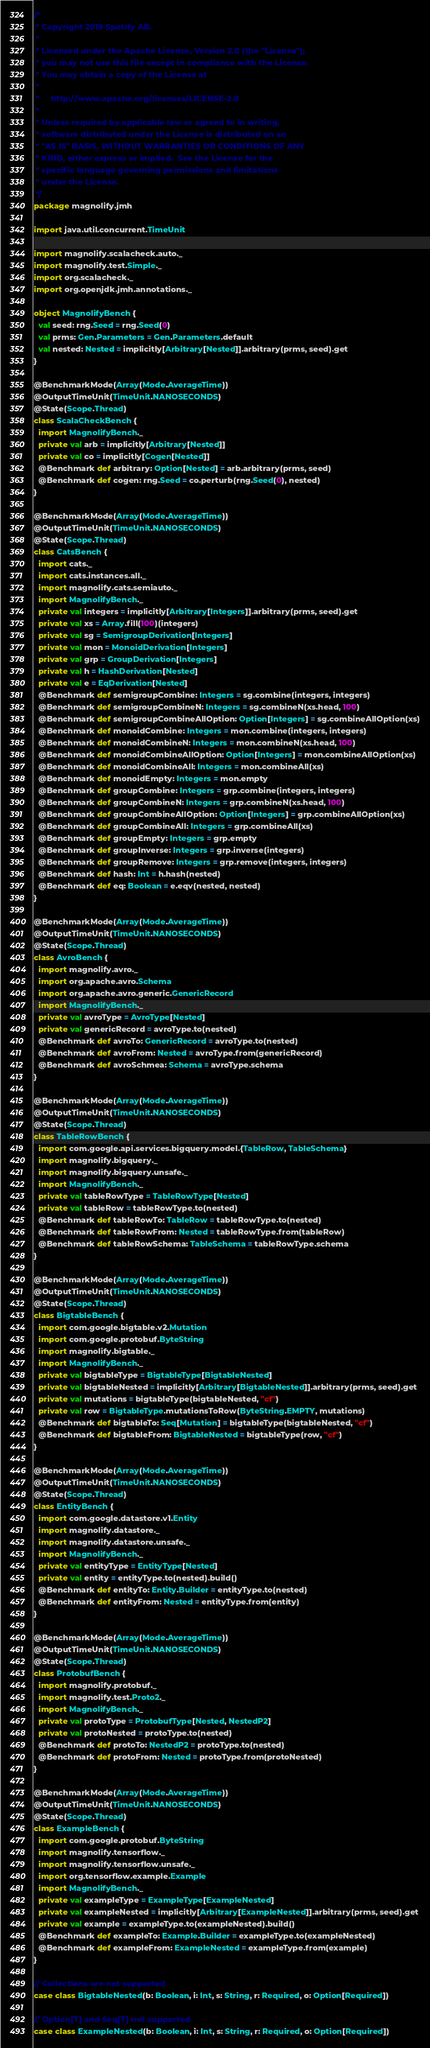<code> <loc_0><loc_0><loc_500><loc_500><_Scala_>/*
 * Copyright 2019 Spotify AB.
 *
 * Licensed under the Apache License, Version 2.0 (the "License");
 * you may not use this file except in compliance with the License.
 * You may obtain a copy of the License at
 *
 *     http://www.apache.org/licenses/LICENSE-2.0
 *
 * Unless required by applicable law or agreed to in writing,
 * software distributed under the License is distributed on an
 * "AS IS" BASIS, WITHOUT WARRANTIES OR CONDITIONS OF ANY
 * KIND, either express or implied.  See the License for the
 * specific language governing permissions and limitations
 * under the License.
 */
package magnolify.jmh

import java.util.concurrent.TimeUnit

import magnolify.scalacheck.auto._
import magnolify.test.Simple._
import org.scalacheck._
import org.openjdk.jmh.annotations._

object MagnolifyBench {
  val seed: rng.Seed = rng.Seed(0)
  val prms: Gen.Parameters = Gen.Parameters.default
  val nested: Nested = implicitly[Arbitrary[Nested]].arbitrary(prms, seed).get
}

@BenchmarkMode(Array(Mode.AverageTime))
@OutputTimeUnit(TimeUnit.NANOSECONDS)
@State(Scope.Thread)
class ScalaCheckBench {
  import MagnolifyBench._
  private val arb = implicitly[Arbitrary[Nested]]
  private val co = implicitly[Cogen[Nested]]
  @Benchmark def arbitrary: Option[Nested] = arb.arbitrary(prms, seed)
  @Benchmark def cogen: rng.Seed = co.perturb(rng.Seed(0), nested)
}

@BenchmarkMode(Array(Mode.AverageTime))
@OutputTimeUnit(TimeUnit.NANOSECONDS)
@State(Scope.Thread)
class CatsBench {
  import cats._
  import cats.instances.all._
  import magnolify.cats.semiauto._
  import MagnolifyBench._
  private val integers = implicitly[Arbitrary[Integers]].arbitrary(prms, seed).get
  private val xs = Array.fill(100)(integers)
  private val sg = SemigroupDerivation[Integers]
  private val mon = MonoidDerivation[Integers]
  private val grp = GroupDerivation[Integers]
  private val h = HashDerivation[Nested]
  private val e = EqDerivation[Nested]
  @Benchmark def semigroupCombine: Integers = sg.combine(integers, integers)
  @Benchmark def semigroupCombineN: Integers = sg.combineN(xs.head, 100)
  @Benchmark def semigroupCombineAllOption: Option[Integers] = sg.combineAllOption(xs)
  @Benchmark def monoidCombine: Integers = mon.combine(integers, integers)
  @Benchmark def monoidCombineN: Integers = mon.combineN(xs.head, 100)
  @Benchmark def monoidCombineAllOption: Option[Integers] = mon.combineAllOption(xs)
  @Benchmark def monoidCombineAll: Integers = mon.combineAll(xs)
  @Benchmark def monoidEmpty: Integers = mon.empty
  @Benchmark def groupCombine: Integers = grp.combine(integers, integers)
  @Benchmark def groupCombineN: Integers = grp.combineN(xs.head, 100)
  @Benchmark def groupCombineAllOption: Option[Integers] = grp.combineAllOption(xs)
  @Benchmark def groupCombineAll: Integers = grp.combineAll(xs)
  @Benchmark def groupEmpty: Integers = grp.empty
  @Benchmark def groupInverse: Integers = grp.inverse(integers)
  @Benchmark def groupRemove: Integers = grp.remove(integers, integers)
  @Benchmark def hash: Int = h.hash(nested)
  @Benchmark def eq: Boolean = e.eqv(nested, nested)
}

@BenchmarkMode(Array(Mode.AverageTime))
@OutputTimeUnit(TimeUnit.NANOSECONDS)
@State(Scope.Thread)
class AvroBench {
  import magnolify.avro._
  import org.apache.avro.Schema
  import org.apache.avro.generic.GenericRecord
  import MagnolifyBench._
  private val avroType = AvroType[Nested]
  private val genericRecord = avroType.to(nested)
  @Benchmark def avroTo: GenericRecord = avroType.to(nested)
  @Benchmark def avroFrom: Nested = avroType.from(genericRecord)
  @Benchmark def avroSchmea: Schema = avroType.schema
}

@BenchmarkMode(Array(Mode.AverageTime))
@OutputTimeUnit(TimeUnit.NANOSECONDS)
@State(Scope.Thread)
class TableRowBench {
  import com.google.api.services.bigquery.model.{TableRow, TableSchema}
  import magnolify.bigquery._
  import magnolify.bigquery.unsafe._
  import MagnolifyBench._
  private val tableRowType = TableRowType[Nested]
  private val tableRow = tableRowType.to(nested)
  @Benchmark def tableRowTo: TableRow = tableRowType.to(nested)
  @Benchmark def tableRowFrom: Nested = tableRowType.from(tableRow)
  @Benchmark def tableRowSchema: TableSchema = tableRowType.schema
}

@BenchmarkMode(Array(Mode.AverageTime))
@OutputTimeUnit(TimeUnit.NANOSECONDS)
@State(Scope.Thread)
class BigtableBench {
  import com.google.bigtable.v2.Mutation
  import com.google.protobuf.ByteString
  import magnolify.bigtable._
  import MagnolifyBench._
  private val bigtableType = BigtableType[BigtableNested]
  private val bigtableNested = implicitly[Arbitrary[BigtableNested]].arbitrary(prms, seed).get
  private val mutations = bigtableType(bigtableNested, "cf")
  private val row = BigtableType.mutationsToRow(ByteString.EMPTY, mutations)
  @Benchmark def bigtableTo: Seq[Mutation] = bigtableType(bigtableNested, "cf")
  @Benchmark def bigtableFrom: BigtableNested = bigtableType(row, "cf")
}

@BenchmarkMode(Array(Mode.AverageTime))
@OutputTimeUnit(TimeUnit.NANOSECONDS)
@State(Scope.Thread)
class EntityBench {
  import com.google.datastore.v1.Entity
  import magnolify.datastore._
  import magnolify.datastore.unsafe._
  import MagnolifyBench._
  private val entityType = EntityType[Nested]
  private val entity = entityType.to(nested).build()
  @Benchmark def entityTo: Entity.Builder = entityType.to(nested)
  @Benchmark def entityFrom: Nested = entityType.from(entity)
}

@BenchmarkMode(Array(Mode.AverageTime))
@OutputTimeUnit(TimeUnit.NANOSECONDS)
@State(Scope.Thread)
class ProtobufBench {
  import magnolify.protobuf._
  import magnolify.test.Proto2._
  import MagnolifyBench._
  private val protoType = ProtobufType[Nested, NestedP2]
  private val protoNested = protoType.to(nested)
  @Benchmark def protoTo: NestedP2 = protoType.to(nested)
  @Benchmark def protoFrom: Nested = protoType.from(protoNested)
}

@BenchmarkMode(Array(Mode.AverageTime))
@OutputTimeUnit(TimeUnit.NANOSECONDS)
@State(Scope.Thread)
class ExampleBench {
  import com.google.protobuf.ByteString
  import magnolify.tensorflow._
  import magnolify.tensorflow.unsafe._
  import org.tensorflow.example.Example
  import MagnolifyBench._
  private val exampleType = ExampleType[ExampleNested]
  private val exampleNested = implicitly[Arbitrary[ExampleNested]].arbitrary(prms, seed).get
  private val example = exampleType.to(exampleNested).build()
  @Benchmark def exampleTo: Example.Builder = exampleType.to(exampleNested)
  @Benchmark def exampleFrom: ExampleNested = exampleType.from(example)
}

// Collections are not supported
case class BigtableNested(b: Boolean, i: Int, s: String, r: Required, o: Option[Required])

// Option[T] and Seq[T] not supported
case class ExampleNested(b: Boolean, i: Int, s: String, r: Required, o: Option[Required])
</code> 